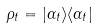<formula> <loc_0><loc_0><loc_500><loc_500>\rho _ { t } = | \alpha _ { t } \rangle \langle \alpha _ { t } |</formula> 